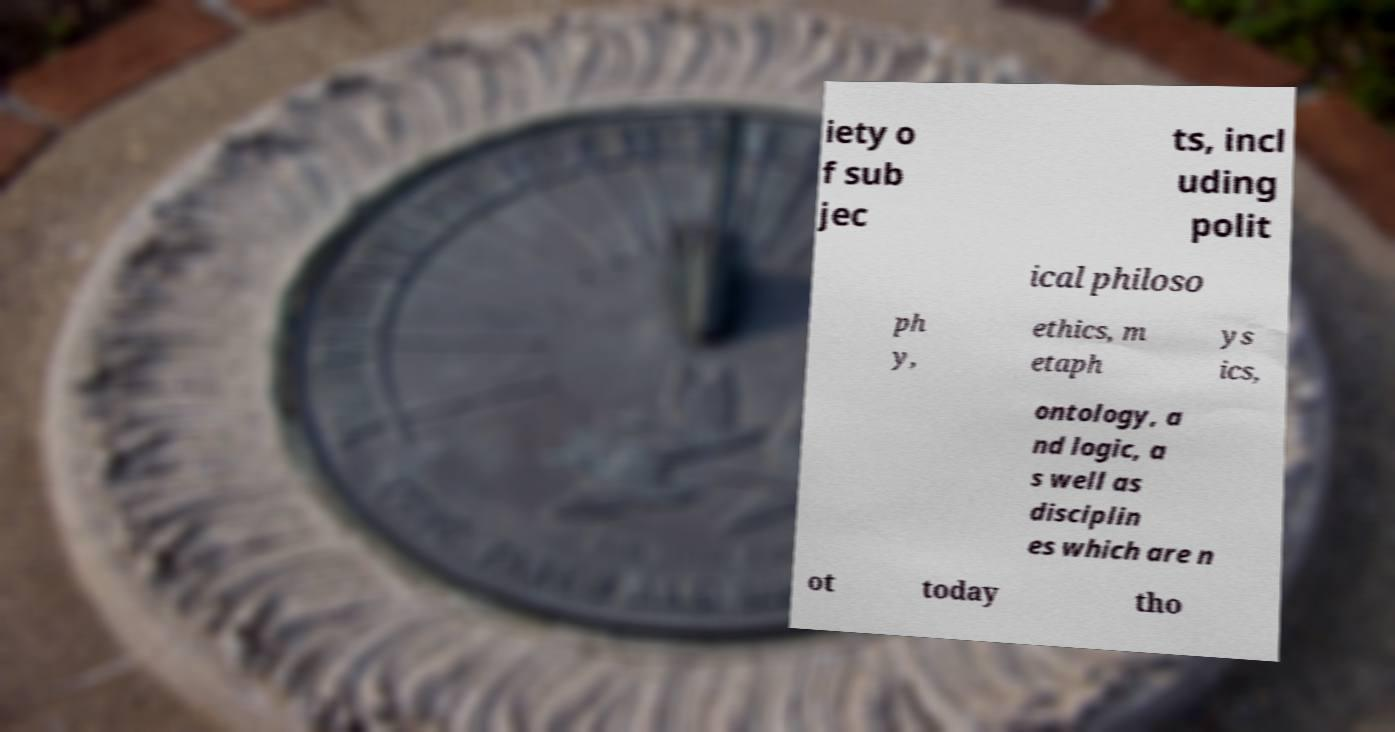Can you read and provide the text displayed in the image?This photo seems to have some interesting text. Can you extract and type it out for me? iety o f sub jec ts, incl uding polit ical philoso ph y, ethics, m etaph ys ics, ontology, a nd logic, a s well as disciplin es which are n ot today tho 